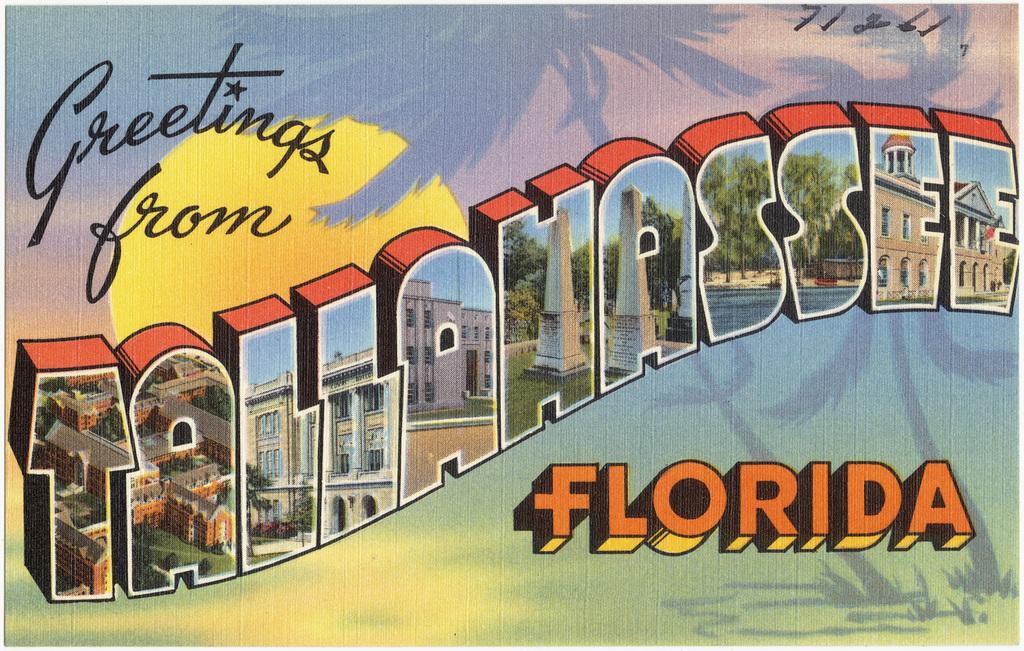What is the title of this postcard?
Make the answer very short. Greetings from tallahassee florida. 